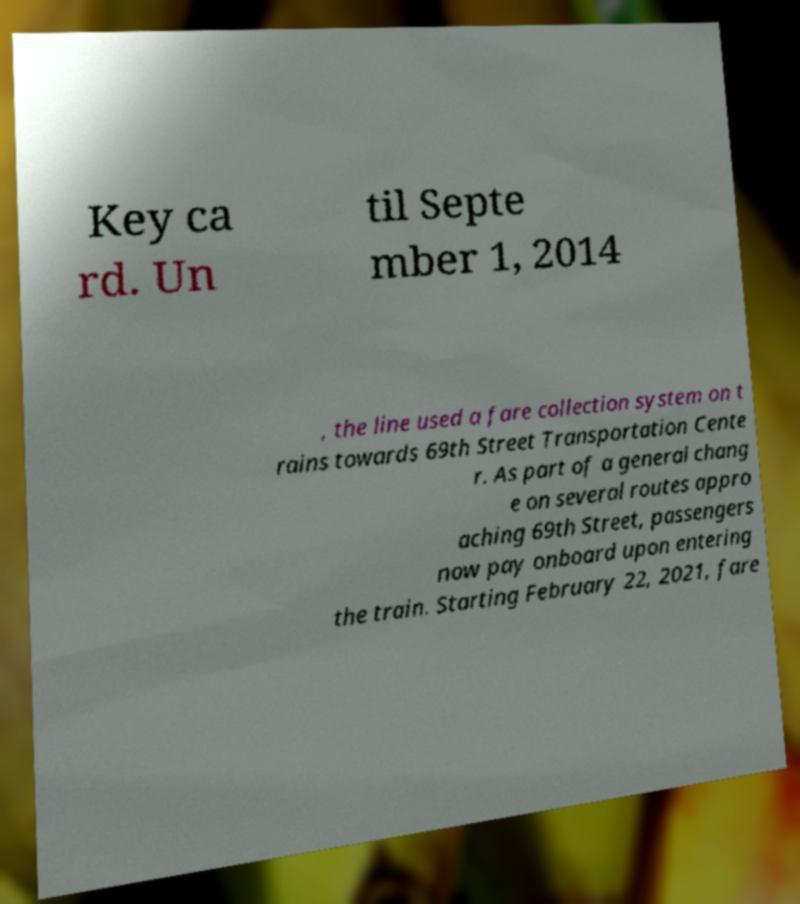Please read and relay the text visible in this image. What does it say? Key ca rd. Un til Septe mber 1, 2014 , the line used a fare collection system on t rains towards 69th Street Transportation Cente r. As part of a general chang e on several routes appro aching 69th Street, passengers now pay onboard upon entering the train. Starting February 22, 2021, fare 